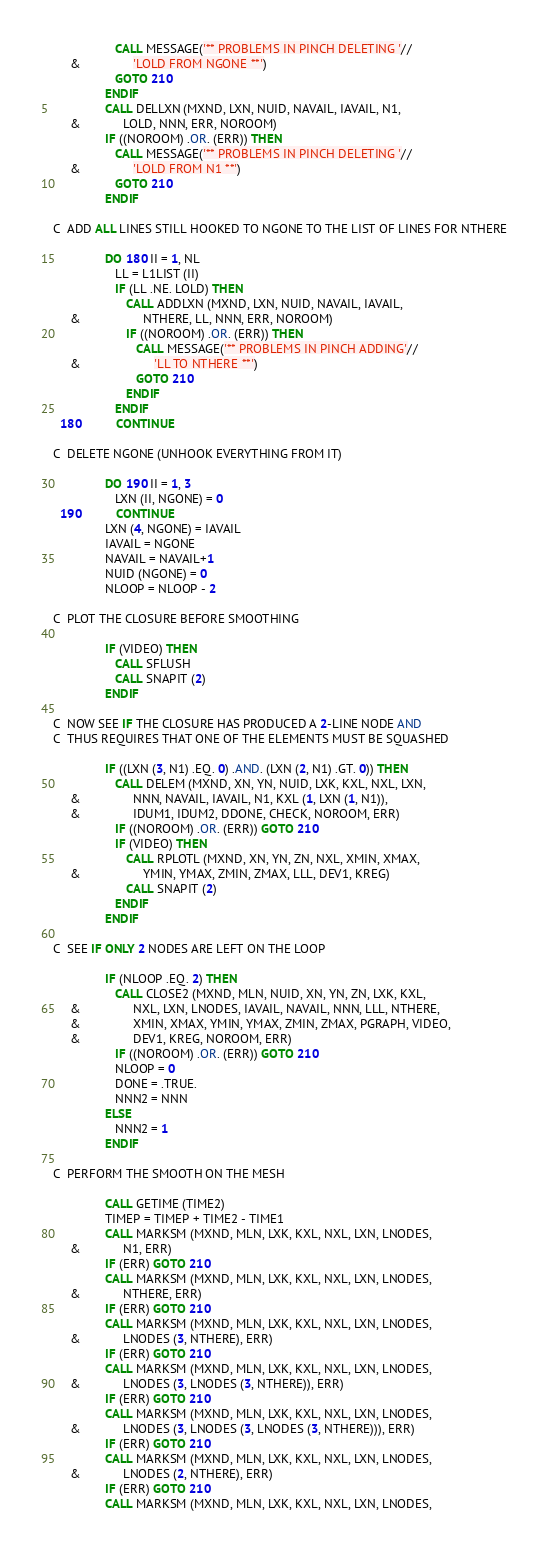<code> <loc_0><loc_0><loc_500><loc_500><_FORTRAN_>                  CALL MESSAGE('** PROBLEMS IN PINCH DELETING '//
     &               'LOLD FROM NGONE **')
                  GOTO 210
               ENDIF
               CALL DELLXN (MXND, LXN, NUID, NAVAIL, IAVAIL, N1,
     &            LOLD, NNN, ERR, NOROOM)
               IF ((NOROOM) .OR. (ERR)) THEN
                  CALL MESSAGE('** PROBLEMS IN PINCH DELETING '//
     &               'LOLD FROM N1 **')
                  GOTO 210
               ENDIF

C  ADD ALL LINES STILL HOOKED TO NGONE TO THE LIST OF LINES FOR NTHERE

               DO 180 II = 1, NL
                  LL = L1LIST (II)
                  IF (LL .NE. LOLD) THEN
                     CALL ADDLXN (MXND, LXN, NUID, NAVAIL, IAVAIL,
     &                  NTHERE, LL, NNN, ERR, NOROOM)
                     IF ((NOROOM) .OR. (ERR)) THEN
                        CALL MESSAGE('** PROBLEMS IN PINCH ADDING'//
     &                     'LL TO NTHERE **')
                        GOTO 210
                     ENDIF
                  ENDIF
  180          CONTINUE

C  DELETE NGONE (UNHOOK EVERYTHING FROM IT)

               DO 190 II = 1, 3
                  LXN (II, NGONE) = 0
  190          CONTINUE
               LXN (4, NGONE) = IAVAIL
               IAVAIL = NGONE
               NAVAIL = NAVAIL+1
               NUID (NGONE) = 0
               NLOOP = NLOOP - 2

C  PLOT THE CLOSURE BEFORE SMOOTHING

               IF (VIDEO) THEN
                  CALL SFLUSH
                  CALL SNAPIT (2)
               ENDIF

C  NOW SEE IF THE CLOSURE HAS PRODUCED A 2-LINE NODE AND
C  THUS REQUIRES THAT ONE OF THE ELEMENTS MUST BE SQUASHED

               IF ((LXN (3, N1) .EQ. 0) .AND. (LXN (2, N1) .GT. 0)) THEN
                  CALL DELEM (MXND, XN, YN, NUID, LXK, KXL, NXL, LXN,
     &               NNN, NAVAIL, IAVAIL, N1, KXL (1, LXN (1, N1)),
     &               IDUM1, IDUM2, DDONE, CHECK, NOROOM, ERR)
                  IF ((NOROOM) .OR. (ERR)) GOTO 210
                  IF (VIDEO) THEN
                     CALL RPLOTL (MXND, XN, YN, ZN, NXL, XMIN, XMAX,
     &                  YMIN, YMAX, ZMIN, ZMAX, LLL, DEV1, KREG)
                     CALL SNAPIT (2)
                  ENDIF
               ENDIF

C  SEE IF ONLY 2 NODES ARE LEFT ON THE LOOP

               IF (NLOOP .EQ. 2) THEN
                  CALL CLOSE2 (MXND, MLN, NUID, XN, YN, ZN, LXK, KXL,
     &               NXL, LXN, LNODES, IAVAIL, NAVAIL, NNN, LLL, NTHERE,
     &               XMIN, XMAX, YMIN, YMAX, ZMIN, ZMAX, PGRAPH, VIDEO,
     &               DEV1, KREG, NOROOM, ERR)
                  IF ((NOROOM) .OR. (ERR)) GOTO 210
                  NLOOP = 0
                  DONE = .TRUE.
                  NNN2 = NNN
               ELSE
                  NNN2 = 1
               ENDIF

C  PERFORM THE SMOOTH ON THE MESH

               CALL GETIME (TIME2)
               TIMEP = TIMEP + TIME2 - TIME1
               CALL MARKSM (MXND, MLN, LXK, KXL, NXL, LXN, LNODES,
     &            N1, ERR)
               IF (ERR) GOTO 210
               CALL MARKSM (MXND, MLN, LXK, KXL, NXL, LXN, LNODES,
     &            NTHERE, ERR)
               IF (ERR) GOTO 210
               CALL MARKSM (MXND, MLN, LXK, KXL, NXL, LXN, LNODES,
     &            LNODES (3, NTHERE), ERR)
               IF (ERR) GOTO 210
               CALL MARKSM (MXND, MLN, LXK, KXL, NXL, LXN, LNODES,
     &            LNODES (3, LNODES (3, NTHERE)), ERR)
               IF (ERR) GOTO 210
               CALL MARKSM (MXND, MLN, LXK, KXL, NXL, LXN, LNODES,
     &            LNODES (3, LNODES (3, LNODES (3, NTHERE))), ERR)
               IF (ERR) GOTO 210
               CALL MARKSM (MXND, MLN, LXK, KXL, NXL, LXN, LNODES,
     &            LNODES (2, NTHERE), ERR)
               IF (ERR) GOTO 210
               CALL MARKSM (MXND, MLN, LXK, KXL, NXL, LXN, LNODES,</code> 